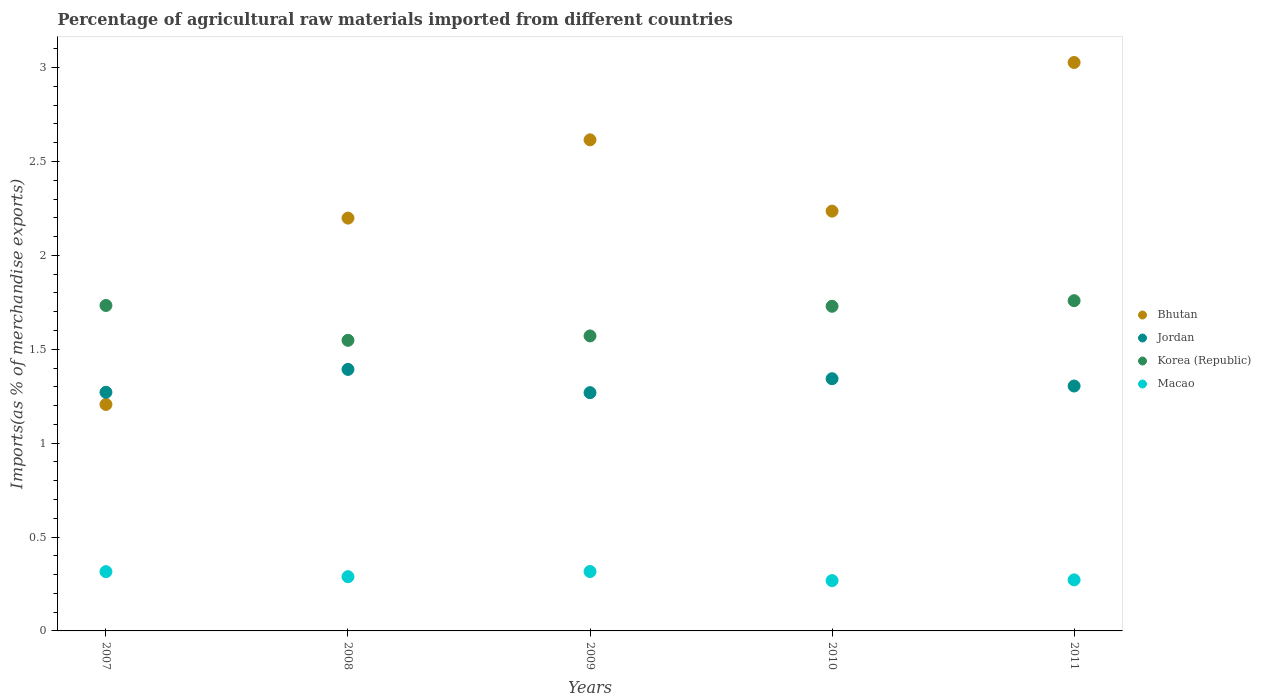What is the percentage of imports to different countries in Korea (Republic) in 2007?
Offer a terse response. 1.73. Across all years, what is the maximum percentage of imports to different countries in Bhutan?
Keep it short and to the point. 3.03. Across all years, what is the minimum percentage of imports to different countries in Jordan?
Keep it short and to the point. 1.27. In which year was the percentage of imports to different countries in Jordan maximum?
Your answer should be compact. 2008. In which year was the percentage of imports to different countries in Korea (Republic) minimum?
Keep it short and to the point. 2008. What is the total percentage of imports to different countries in Macao in the graph?
Provide a short and direct response. 1.46. What is the difference between the percentage of imports to different countries in Macao in 2007 and that in 2009?
Give a very brief answer. -0. What is the difference between the percentage of imports to different countries in Jordan in 2007 and the percentage of imports to different countries in Korea (Republic) in 2010?
Give a very brief answer. -0.46. What is the average percentage of imports to different countries in Jordan per year?
Offer a very short reply. 1.32. In the year 2008, what is the difference between the percentage of imports to different countries in Bhutan and percentage of imports to different countries in Jordan?
Your answer should be compact. 0.81. What is the ratio of the percentage of imports to different countries in Bhutan in 2009 to that in 2011?
Offer a terse response. 0.86. Is the percentage of imports to different countries in Korea (Republic) in 2008 less than that in 2011?
Give a very brief answer. Yes. Is the difference between the percentage of imports to different countries in Bhutan in 2007 and 2008 greater than the difference between the percentage of imports to different countries in Jordan in 2007 and 2008?
Offer a very short reply. No. What is the difference between the highest and the second highest percentage of imports to different countries in Bhutan?
Give a very brief answer. 0.41. What is the difference between the highest and the lowest percentage of imports to different countries in Bhutan?
Keep it short and to the point. 1.82. In how many years, is the percentage of imports to different countries in Macao greater than the average percentage of imports to different countries in Macao taken over all years?
Make the answer very short. 2. Is the percentage of imports to different countries in Korea (Republic) strictly greater than the percentage of imports to different countries in Macao over the years?
Offer a terse response. Yes. Is the percentage of imports to different countries in Jordan strictly less than the percentage of imports to different countries in Korea (Republic) over the years?
Offer a very short reply. Yes. How many years are there in the graph?
Offer a terse response. 5. Are the values on the major ticks of Y-axis written in scientific E-notation?
Offer a very short reply. No. Does the graph contain any zero values?
Your response must be concise. No. Where does the legend appear in the graph?
Provide a succinct answer. Center right. How are the legend labels stacked?
Ensure brevity in your answer.  Vertical. What is the title of the graph?
Offer a very short reply. Percentage of agricultural raw materials imported from different countries. What is the label or title of the Y-axis?
Your answer should be very brief. Imports(as % of merchandise exports). What is the Imports(as % of merchandise exports) in Bhutan in 2007?
Keep it short and to the point. 1.21. What is the Imports(as % of merchandise exports) in Jordan in 2007?
Your answer should be very brief. 1.27. What is the Imports(as % of merchandise exports) of Korea (Republic) in 2007?
Your response must be concise. 1.73. What is the Imports(as % of merchandise exports) of Macao in 2007?
Ensure brevity in your answer.  0.32. What is the Imports(as % of merchandise exports) in Bhutan in 2008?
Offer a terse response. 2.2. What is the Imports(as % of merchandise exports) in Jordan in 2008?
Give a very brief answer. 1.39. What is the Imports(as % of merchandise exports) in Korea (Republic) in 2008?
Ensure brevity in your answer.  1.55. What is the Imports(as % of merchandise exports) in Macao in 2008?
Give a very brief answer. 0.29. What is the Imports(as % of merchandise exports) of Bhutan in 2009?
Ensure brevity in your answer.  2.62. What is the Imports(as % of merchandise exports) in Jordan in 2009?
Provide a short and direct response. 1.27. What is the Imports(as % of merchandise exports) of Korea (Republic) in 2009?
Your response must be concise. 1.57. What is the Imports(as % of merchandise exports) in Macao in 2009?
Give a very brief answer. 0.32. What is the Imports(as % of merchandise exports) in Bhutan in 2010?
Make the answer very short. 2.24. What is the Imports(as % of merchandise exports) of Jordan in 2010?
Offer a terse response. 1.34. What is the Imports(as % of merchandise exports) of Korea (Republic) in 2010?
Your response must be concise. 1.73. What is the Imports(as % of merchandise exports) in Macao in 2010?
Provide a succinct answer. 0.27. What is the Imports(as % of merchandise exports) of Bhutan in 2011?
Keep it short and to the point. 3.03. What is the Imports(as % of merchandise exports) in Jordan in 2011?
Offer a very short reply. 1.3. What is the Imports(as % of merchandise exports) in Korea (Republic) in 2011?
Provide a succinct answer. 1.76. What is the Imports(as % of merchandise exports) in Macao in 2011?
Make the answer very short. 0.27. Across all years, what is the maximum Imports(as % of merchandise exports) in Bhutan?
Give a very brief answer. 3.03. Across all years, what is the maximum Imports(as % of merchandise exports) of Jordan?
Give a very brief answer. 1.39. Across all years, what is the maximum Imports(as % of merchandise exports) in Korea (Republic)?
Make the answer very short. 1.76. Across all years, what is the maximum Imports(as % of merchandise exports) in Macao?
Offer a terse response. 0.32. Across all years, what is the minimum Imports(as % of merchandise exports) of Bhutan?
Offer a very short reply. 1.21. Across all years, what is the minimum Imports(as % of merchandise exports) in Jordan?
Give a very brief answer. 1.27. Across all years, what is the minimum Imports(as % of merchandise exports) in Korea (Republic)?
Offer a very short reply. 1.55. Across all years, what is the minimum Imports(as % of merchandise exports) in Macao?
Provide a succinct answer. 0.27. What is the total Imports(as % of merchandise exports) of Bhutan in the graph?
Give a very brief answer. 11.28. What is the total Imports(as % of merchandise exports) in Jordan in the graph?
Make the answer very short. 6.58. What is the total Imports(as % of merchandise exports) in Korea (Republic) in the graph?
Your response must be concise. 8.34. What is the total Imports(as % of merchandise exports) of Macao in the graph?
Give a very brief answer. 1.46. What is the difference between the Imports(as % of merchandise exports) of Bhutan in 2007 and that in 2008?
Ensure brevity in your answer.  -0.99. What is the difference between the Imports(as % of merchandise exports) of Jordan in 2007 and that in 2008?
Your answer should be very brief. -0.12. What is the difference between the Imports(as % of merchandise exports) in Korea (Republic) in 2007 and that in 2008?
Your answer should be very brief. 0.19. What is the difference between the Imports(as % of merchandise exports) of Macao in 2007 and that in 2008?
Offer a terse response. 0.03. What is the difference between the Imports(as % of merchandise exports) in Bhutan in 2007 and that in 2009?
Offer a terse response. -1.41. What is the difference between the Imports(as % of merchandise exports) in Jordan in 2007 and that in 2009?
Your answer should be very brief. 0. What is the difference between the Imports(as % of merchandise exports) of Korea (Republic) in 2007 and that in 2009?
Keep it short and to the point. 0.16. What is the difference between the Imports(as % of merchandise exports) of Macao in 2007 and that in 2009?
Offer a terse response. -0. What is the difference between the Imports(as % of merchandise exports) of Bhutan in 2007 and that in 2010?
Make the answer very short. -1.03. What is the difference between the Imports(as % of merchandise exports) in Jordan in 2007 and that in 2010?
Your answer should be compact. -0.07. What is the difference between the Imports(as % of merchandise exports) of Korea (Republic) in 2007 and that in 2010?
Your answer should be very brief. 0. What is the difference between the Imports(as % of merchandise exports) in Macao in 2007 and that in 2010?
Ensure brevity in your answer.  0.05. What is the difference between the Imports(as % of merchandise exports) of Bhutan in 2007 and that in 2011?
Provide a succinct answer. -1.82. What is the difference between the Imports(as % of merchandise exports) of Jordan in 2007 and that in 2011?
Your answer should be very brief. -0.03. What is the difference between the Imports(as % of merchandise exports) in Korea (Republic) in 2007 and that in 2011?
Offer a terse response. -0.03. What is the difference between the Imports(as % of merchandise exports) of Macao in 2007 and that in 2011?
Make the answer very short. 0.04. What is the difference between the Imports(as % of merchandise exports) in Bhutan in 2008 and that in 2009?
Offer a terse response. -0.42. What is the difference between the Imports(as % of merchandise exports) of Jordan in 2008 and that in 2009?
Your answer should be compact. 0.12. What is the difference between the Imports(as % of merchandise exports) of Korea (Republic) in 2008 and that in 2009?
Ensure brevity in your answer.  -0.02. What is the difference between the Imports(as % of merchandise exports) in Macao in 2008 and that in 2009?
Your answer should be very brief. -0.03. What is the difference between the Imports(as % of merchandise exports) in Bhutan in 2008 and that in 2010?
Ensure brevity in your answer.  -0.04. What is the difference between the Imports(as % of merchandise exports) of Jordan in 2008 and that in 2010?
Offer a very short reply. 0.05. What is the difference between the Imports(as % of merchandise exports) of Korea (Republic) in 2008 and that in 2010?
Your answer should be compact. -0.18. What is the difference between the Imports(as % of merchandise exports) of Macao in 2008 and that in 2010?
Keep it short and to the point. 0.02. What is the difference between the Imports(as % of merchandise exports) in Bhutan in 2008 and that in 2011?
Your answer should be compact. -0.83. What is the difference between the Imports(as % of merchandise exports) of Jordan in 2008 and that in 2011?
Give a very brief answer. 0.09. What is the difference between the Imports(as % of merchandise exports) in Korea (Republic) in 2008 and that in 2011?
Provide a succinct answer. -0.21. What is the difference between the Imports(as % of merchandise exports) in Macao in 2008 and that in 2011?
Your answer should be compact. 0.02. What is the difference between the Imports(as % of merchandise exports) of Bhutan in 2009 and that in 2010?
Ensure brevity in your answer.  0.38. What is the difference between the Imports(as % of merchandise exports) of Jordan in 2009 and that in 2010?
Offer a very short reply. -0.07. What is the difference between the Imports(as % of merchandise exports) in Korea (Republic) in 2009 and that in 2010?
Make the answer very short. -0.16. What is the difference between the Imports(as % of merchandise exports) in Macao in 2009 and that in 2010?
Your answer should be compact. 0.05. What is the difference between the Imports(as % of merchandise exports) in Bhutan in 2009 and that in 2011?
Offer a very short reply. -0.41. What is the difference between the Imports(as % of merchandise exports) of Jordan in 2009 and that in 2011?
Give a very brief answer. -0.04. What is the difference between the Imports(as % of merchandise exports) in Korea (Republic) in 2009 and that in 2011?
Make the answer very short. -0.19. What is the difference between the Imports(as % of merchandise exports) of Macao in 2009 and that in 2011?
Give a very brief answer. 0.04. What is the difference between the Imports(as % of merchandise exports) in Bhutan in 2010 and that in 2011?
Your answer should be compact. -0.79. What is the difference between the Imports(as % of merchandise exports) of Jordan in 2010 and that in 2011?
Provide a short and direct response. 0.04. What is the difference between the Imports(as % of merchandise exports) in Korea (Republic) in 2010 and that in 2011?
Your answer should be compact. -0.03. What is the difference between the Imports(as % of merchandise exports) of Macao in 2010 and that in 2011?
Make the answer very short. -0. What is the difference between the Imports(as % of merchandise exports) of Bhutan in 2007 and the Imports(as % of merchandise exports) of Jordan in 2008?
Offer a very short reply. -0.19. What is the difference between the Imports(as % of merchandise exports) of Bhutan in 2007 and the Imports(as % of merchandise exports) of Korea (Republic) in 2008?
Provide a succinct answer. -0.34. What is the difference between the Imports(as % of merchandise exports) of Bhutan in 2007 and the Imports(as % of merchandise exports) of Macao in 2008?
Provide a succinct answer. 0.92. What is the difference between the Imports(as % of merchandise exports) of Jordan in 2007 and the Imports(as % of merchandise exports) of Korea (Republic) in 2008?
Keep it short and to the point. -0.28. What is the difference between the Imports(as % of merchandise exports) in Jordan in 2007 and the Imports(as % of merchandise exports) in Macao in 2008?
Give a very brief answer. 0.98. What is the difference between the Imports(as % of merchandise exports) in Korea (Republic) in 2007 and the Imports(as % of merchandise exports) in Macao in 2008?
Provide a short and direct response. 1.44. What is the difference between the Imports(as % of merchandise exports) of Bhutan in 2007 and the Imports(as % of merchandise exports) of Jordan in 2009?
Offer a very short reply. -0.06. What is the difference between the Imports(as % of merchandise exports) in Bhutan in 2007 and the Imports(as % of merchandise exports) in Korea (Republic) in 2009?
Make the answer very short. -0.36. What is the difference between the Imports(as % of merchandise exports) in Bhutan in 2007 and the Imports(as % of merchandise exports) in Macao in 2009?
Offer a terse response. 0.89. What is the difference between the Imports(as % of merchandise exports) in Jordan in 2007 and the Imports(as % of merchandise exports) in Korea (Republic) in 2009?
Your response must be concise. -0.3. What is the difference between the Imports(as % of merchandise exports) in Jordan in 2007 and the Imports(as % of merchandise exports) in Macao in 2009?
Your response must be concise. 0.95. What is the difference between the Imports(as % of merchandise exports) of Korea (Republic) in 2007 and the Imports(as % of merchandise exports) of Macao in 2009?
Ensure brevity in your answer.  1.42. What is the difference between the Imports(as % of merchandise exports) in Bhutan in 2007 and the Imports(as % of merchandise exports) in Jordan in 2010?
Make the answer very short. -0.14. What is the difference between the Imports(as % of merchandise exports) of Bhutan in 2007 and the Imports(as % of merchandise exports) of Korea (Republic) in 2010?
Ensure brevity in your answer.  -0.52. What is the difference between the Imports(as % of merchandise exports) in Bhutan in 2007 and the Imports(as % of merchandise exports) in Macao in 2010?
Offer a very short reply. 0.94. What is the difference between the Imports(as % of merchandise exports) in Jordan in 2007 and the Imports(as % of merchandise exports) in Korea (Republic) in 2010?
Provide a short and direct response. -0.46. What is the difference between the Imports(as % of merchandise exports) of Korea (Republic) in 2007 and the Imports(as % of merchandise exports) of Macao in 2010?
Your answer should be compact. 1.47. What is the difference between the Imports(as % of merchandise exports) in Bhutan in 2007 and the Imports(as % of merchandise exports) in Jordan in 2011?
Make the answer very short. -0.1. What is the difference between the Imports(as % of merchandise exports) in Bhutan in 2007 and the Imports(as % of merchandise exports) in Korea (Republic) in 2011?
Make the answer very short. -0.55. What is the difference between the Imports(as % of merchandise exports) of Bhutan in 2007 and the Imports(as % of merchandise exports) of Macao in 2011?
Provide a succinct answer. 0.93. What is the difference between the Imports(as % of merchandise exports) of Jordan in 2007 and the Imports(as % of merchandise exports) of Korea (Republic) in 2011?
Make the answer very short. -0.49. What is the difference between the Imports(as % of merchandise exports) in Korea (Republic) in 2007 and the Imports(as % of merchandise exports) in Macao in 2011?
Make the answer very short. 1.46. What is the difference between the Imports(as % of merchandise exports) in Bhutan in 2008 and the Imports(as % of merchandise exports) in Jordan in 2009?
Your answer should be compact. 0.93. What is the difference between the Imports(as % of merchandise exports) of Bhutan in 2008 and the Imports(as % of merchandise exports) of Korea (Republic) in 2009?
Offer a very short reply. 0.63. What is the difference between the Imports(as % of merchandise exports) of Bhutan in 2008 and the Imports(as % of merchandise exports) of Macao in 2009?
Keep it short and to the point. 1.88. What is the difference between the Imports(as % of merchandise exports) of Jordan in 2008 and the Imports(as % of merchandise exports) of Korea (Republic) in 2009?
Make the answer very short. -0.18. What is the difference between the Imports(as % of merchandise exports) of Jordan in 2008 and the Imports(as % of merchandise exports) of Macao in 2009?
Make the answer very short. 1.08. What is the difference between the Imports(as % of merchandise exports) in Korea (Republic) in 2008 and the Imports(as % of merchandise exports) in Macao in 2009?
Make the answer very short. 1.23. What is the difference between the Imports(as % of merchandise exports) of Bhutan in 2008 and the Imports(as % of merchandise exports) of Jordan in 2010?
Give a very brief answer. 0.86. What is the difference between the Imports(as % of merchandise exports) in Bhutan in 2008 and the Imports(as % of merchandise exports) in Korea (Republic) in 2010?
Offer a very short reply. 0.47. What is the difference between the Imports(as % of merchandise exports) in Bhutan in 2008 and the Imports(as % of merchandise exports) in Macao in 2010?
Provide a short and direct response. 1.93. What is the difference between the Imports(as % of merchandise exports) of Jordan in 2008 and the Imports(as % of merchandise exports) of Korea (Republic) in 2010?
Your answer should be compact. -0.34. What is the difference between the Imports(as % of merchandise exports) of Jordan in 2008 and the Imports(as % of merchandise exports) of Macao in 2010?
Your answer should be compact. 1.12. What is the difference between the Imports(as % of merchandise exports) in Korea (Republic) in 2008 and the Imports(as % of merchandise exports) in Macao in 2010?
Your response must be concise. 1.28. What is the difference between the Imports(as % of merchandise exports) in Bhutan in 2008 and the Imports(as % of merchandise exports) in Jordan in 2011?
Offer a very short reply. 0.89. What is the difference between the Imports(as % of merchandise exports) of Bhutan in 2008 and the Imports(as % of merchandise exports) of Korea (Republic) in 2011?
Ensure brevity in your answer.  0.44. What is the difference between the Imports(as % of merchandise exports) of Bhutan in 2008 and the Imports(as % of merchandise exports) of Macao in 2011?
Keep it short and to the point. 1.93. What is the difference between the Imports(as % of merchandise exports) of Jordan in 2008 and the Imports(as % of merchandise exports) of Korea (Republic) in 2011?
Give a very brief answer. -0.37. What is the difference between the Imports(as % of merchandise exports) of Jordan in 2008 and the Imports(as % of merchandise exports) of Macao in 2011?
Provide a short and direct response. 1.12. What is the difference between the Imports(as % of merchandise exports) in Korea (Republic) in 2008 and the Imports(as % of merchandise exports) in Macao in 2011?
Ensure brevity in your answer.  1.28. What is the difference between the Imports(as % of merchandise exports) of Bhutan in 2009 and the Imports(as % of merchandise exports) of Jordan in 2010?
Give a very brief answer. 1.27. What is the difference between the Imports(as % of merchandise exports) in Bhutan in 2009 and the Imports(as % of merchandise exports) in Korea (Republic) in 2010?
Give a very brief answer. 0.89. What is the difference between the Imports(as % of merchandise exports) in Bhutan in 2009 and the Imports(as % of merchandise exports) in Macao in 2010?
Make the answer very short. 2.35. What is the difference between the Imports(as % of merchandise exports) in Jordan in 2009 and the Imports(as % of merchandise exports) in Korea (Republic) in 2010?
Your answer should be very brief. -0.46. What is the difference between the Imports(as % of merchandise exports) of Jordan in 2009 and the Imports(as % of merchandise exports) of Macao in 2010?
Provide a succinct answer. 1. What is the difference between the Imports(as % of merchandise exports) in Korea (Republic) in 2009 and the Imports(as % of merchandise exports) in Macao in 2010?
Ensure brevity in your answer.  1.3. What is the difference between the Imports(as % of merchandise exports) in Bhutan in 2009 and the Imports(as % of merchandise exports) in Jordan in 2011?
Your answer should be compact. 1.31. What is the difference between the Imports(as % of merchandise exports) in Bhutan in 2009 and the Imports(as % of merchandise exports) in Korea (Republic) in 2011?
Offer a terse response. 0.86. What is the difference between the Imports(as % of merchandise exports) of Bhutan in 2009 and the Imports(as % of merchandise exports) of Macao in 2011?
Give a very brief answer. 2.34. What is the difference between the Imports(as % of merchandise exports) in Jordan in 2009 and the Imports(as % of merchandise exports) in Korea (Republic) in 2011?
Offer a very short reply. -0.49. What is the difference between the Imports(as % of merchandise exports) of Jordan in 2009 and the Imports(as % of merchandise exports) of Macao in 2011?
Offer a terse response. 1. What is the difference between the Imports(as % of merchandise exports) of Korea (Republic) in 2009 and the Imports(as % of merchandise exports) of Macao in 2011?
Ensure brevity in your answer.  1.3. What is the difference between the Imports(as % of merchandise exports) in Bhutan in 2010 and the Imports(as % of merchandise exports) in Jordan in 2011?
Your answer should be compact. 0.93. What is the difference between the Imports(as % of merchandise exports) in Bhutan in 2010 and the Imports(as % of merchandise exports) in Korea (Republic) in 2011?
Ensure brevity in your answer.  0.48. What is the difference between the Imports(as % of merchandise exports) in Bhutan in 2010 and the Imports(as % of merchandise exports) in Macao in 2011?
Your response must be concise. 1.96. What is the difference between the Imports(as % of merchandise exports) in Jordan in 2010 and the Imports(as % of merchandise exports) in Korea (Republic) in 2011?
Your response must be concise. -0.42. What is the difference between the Imports(as % of merchandise exports) of Jordan in 2010 and the Imports(as % of merchandise exports) of Macao in 2011?
Your answer should be compact. 1.07. What is the difference between the Imports(as % of merchandise exports) of Korea (Republic) in 2010 and the Imports(as % of merchandise exports) of Macao in 2011?
Your answer should be compact. 1.46. What is the average Imports(as % of merchandise exports) of Bhutan per year?
Offer a very short reply. 2.26. What is the average Imports(as % of merchandise exports) in Jordan per year?
Give a very brief answer. 1.32. What is the average Imports(as % of merchandise exports) of Korea (Republic) per year?
Your response must be concise. 1.67. What is the average Imports(as % of merchandise exports) in Macao per year?
Your response must be concise. 0.29. In the year 2007, what is the difference between the Imports(as % of merchandise exports) of Bhutan and Imports(as % of merchandise exports) of Jordan?
Your response must be concise. -0.06. In the year 2007, what is the difference between the Imports(as % of merchandise exports) in Bhutan and Imports(as % of merchandise exports) in Korea (Republic)?
Provide a succinct answer. -0.53. In the year 2007, what is the difference between the Imports(as % of merchandise exports) in Bhutan and Imports(as % of merchandise exports) in Macao?
Provide a short and direct response. 0.89. In the year 2007, what is the difference between the Imports(as % of merchandise exports) in Jordan and Imports(as % of merchandise exports) in Korea (Republic)?
Ensure brevity in your answer.  -0.46. In the year 2007, what is the difference between the Imports(as % of merchandise exports) in Jordan and Imports(as % of merchandise exports) in Macao?
Offer a very short reply. 0.96. In the year 2007, what is the difference between the Imports(as % of merchandise exports) of Korea (Republic) and Imports(as % of merchandise exports) of Macao?
Your answer should be compact. 1.42. In the year 2008, what is the difference between the Imports(as % of merchandise exports) of Bhutan and Imports(as % of merchandise exports) of Jordan?
Give a very brief answer. 0.81. In the year 2008, what is the difference between the Imports(as % of merchandise exports) of Bhutan and Imports(as % of merchandise exports) of Korea (Republic)?
Your answer should be compact. 0.65. In the year 2008, what is the difference between the Imports(as % of merchandise exports) in Bhutan and Imports(as % of merchandise exports) in Macao?
Offer a terse response. 1.91. In the year 2008, what is the difference between the Imports(as % of merchandise exports) in Jordan and Imports(as % of merchandise exports) in Korea (Republic)?
Give a very brief answer. -0.15. In the year 2008, what is the difference between the Imports(as % of merchandise exports) of Jordan and Imports(as % of merchandise exports) of Macao?
Ensure brevity in your answer.  1.1. In the year 2008, what is the difference between the Imports(as % of merchandise exports) of Korea (Republic) and Imports(as % of merchandise exports) of Macao?
Offer a terse response. 1.26. In the year 2009, what is the difference between the Imports(as % of merchandise exports) in Bhutan and Imports(as % of merchandise exports) in Jordan?
Make the answer very short. 1.35. In the year 2009, what is the difference between the Imports(as % of merchandise exports) in Bhutan and Imports(as % of merchandise exports) in Korea (Republic)?
Give a very brief answer. 1.04. In the year 2009, what is the difference between the Imports(as % of merchandise exports) of Bhutan and Imports(as % of merchandise exports) of Macao?
Your answer should be compact. 2.3. In the year 2009, what is the difference between the Imports(as % of merchandise exports) in Jordan and Imports(as % of merchandise exports) in Korea (Republic)?
Your answer should be very brief. -0.3. In the year 2009, what is the difference between the Imports(as % of merchandise exports) of Jordan and Imports(as % of merchandise exports) of Macao?
Your answer should be very brief. 0.95. In the year 2009, what is the difference between the Imports(as % of merchandise exports) in Korea (Republic) and Imports(as % of merchandise exports) in Macao?
Offer a terse response. 1.25. In the year 2010, what is the difference between the Imports(as % of merchandise exports) of Bhutan and Imports(as % of merchandise exports) of Jordan?
Keep it short and to the point. 0.89. In the year 2010, what is the difference between the Imports(as % of merchandise exports) of Bhutan and Imports(as % of merchandise exports) of Korea (Republic)?
Ensure brevity in your answer.  0.51. In the year 2010, what is the difference between the Imports(as % of merchandise exports) in Bhutan and Imports(as % of merchandise exports) in Macao?
Keep it short and to the point. 1.97. In the year 2010, what is the difference between the Imports(as % of merchandise exports) of Jordan and Imports(as % of merchandise exports) of Korea (Republic)?
Provide a short and direct response. -0.39. In the year 2010, what is the difference between the Imports(as % of merchandise exports) in Jordan and Imports(as % of merchandise exports) in Macao?
Your answer should be compact. 1.08. In the year 2010, what is the difference between the Imports(as % of merchandise exports) of Korea (Republic) and Imports(as % of merchandise exports) of Macao?
Your answer should be compact. 1.46. In the year 2011, what is the difference between the Imports(as % of merchandise exports) in Bhutan and Imports(as % of merchandise exports) in Jordan?
Keep it short and to the point. 1.72. In the year 2011, what is the difference between the Imports(as % of merchandise exports) of Bhutan and Imports(as % of merchandise exports) of Korea (Republic)?
Your answer should be compact. 1.27. In the year 2011, what is the difference between the Imports(as % of merchandise exports) in Bhutan and Imports(as % of merchandise exports) in Macao?
Provide a succinct answer. 2.76. In the year 2011, what is the difference between the Imports(as % of merchandise exports) in Jordan and Imports(as % of merchandise exports) in Korea (Republic)?
Keep it short and to the point. -0.45. In the year 2011, what is the difference between the Imports(as % of merchandise exports) in Jordan and Imports(as % of merchandise exports) in Macao?
Make the answer very short. 1.03. In the year 2011, what is the difference between the Imports(as % of merchandise exports) of Korea (Republic) and Imports(as % of merchandise exports) of Macao?
Keep it short and to the point. 1.49. What is the ratio of the Imports(as % of merchandise exports) in Bhutan in 2007 to that in 2008?
Make the answer very short. 0.55. What is the ratio of the Imports(as % of merchandise exports) of Jordan in 2007 to that in 2008?
Keep it short and to the point. 0.91. What is the ratio of the Imports(as % of merchandise exports) in Korea (Republic) in 2007 to that in 2008?
Your answer should be compact. 1.12. What is the ratio of the Imports(as % of merchandise exports) in Macao in 2007 to that in 2008?
Your answer should be very brief. 1.09. What is the ratio of the Imports(as % of merchandise exports) of Bhutan in 2007 to that in 2009?
Offer a very short reply. 0.46. What is the ratio of the Imports(as % of merchandise exports) in Korea (Republic) in 2007 to that in 2009?
Make the answer very short. 1.1. What is the ratio of the Imports(as % of merchandise exports) of Macao in 2007 to that in 2009?
Your answer should be compact. 1. What is the ratio of the Imports(as % of merchandise exports) of Bhutan in 2007 to that in 2010?
Keep it short and to the point. 0.54. What is the ratio of the Imports(as % of merchandise exports) of Jordan in 2007 to that in 2010?
Keep it short and to the point. 0.95. What is the ratio of the Imports(as % of merchandise exports) in Korea (Republic) in 2007 to that in 2010?
Ensure brevity in your answer.  1. What is the ratio of the Imports(as % of merchandise exports) of Macao in 2007 to that in 2010?
Ensure brevity in your answer.  1.18. What is the ratio of the Imports(as % of merchandise exports) of Bhutan in 2007 to that in 2011?
Your response must be concise. 0.4. What is the ratio of the Imports(as % of merchandise exports) in Jordan in 2007 to that in 2011?
Provide a short and direct response. 0.97. What is the ratio of the Imports(as % of merchandise exports) in Korea (Republic) in 2007 to that in 2011?
Ensure brevity in your answer.  0.99. What is the ratio of the Imports(as % of merchandise exports) of Macao in 2007 to that in 2011?
Your answer should be very brief. 1.16. What is the ratio of the Imports(as % of merchandise exports) of Bhutan in 2008 to that in 2009?
Provide a short and direct response. 0.84. What is the ratio of the Imports(as % of merchandise exports) in Jordan in 2008 to that in 2009?
Provide a succinct answer. 1.1. What is the ratio of the Imports(as % of merchandise exports) in Korea (Republic) in 2008 to that in 2009?
Provide a short and direct response. 0.99. What is the ratio of the Imports(as % of merchandise exports) in Macao in 2008 to that in 2009?
Provide a succinct answer. 0.91. What is the ratio of the Imports(as % of merchandise exports) in Bhutan in 2008 to that in 2010?
Offer a very short reply. 0.98. What is the ratio of the Imports(as % of merchandise exports) in Jordan in 2008 to that in 2010?
Ensure brevity in your answer.  1.04. What is the ratio of the Imports(as % of merchandise exports) in Korea (Republic) in 2008 to that in 2010?
Ensure brevity in your answer.  0.9. What is the ratio of the Imports(as % of merchandise exports) in Macao in 2008 to that in 2010?
Provide a short and direct response. 1.08. What is the ratio of the Imports(as % of merchandise exports) of Bhutan in 2008 to that in 2011?
Give a very brief answer. 0.73. What is the ratio of the Imports(as % of merchandise exports) of Jordan in 2008 to that in 2011?
Your answer should be very brief. 1.07. What is the ratio of the Imports(as % of merchandise exports) of Korea (Republic) in 2008 to that in 2011?
Ensure brevity in your answer.  0.88. What is the ratio of the Imports(as % of merchandise exports) in Bhutan in 2009 to that in 2010?
Offer a terse response. 1.17. What is the ratio of the Imports(as % of merchandise exports) of Jordan in 2009 to that in 2010?
Provide a short and direct response. 0.94. What is the ratio of the Imports(as % of merchandise exports) in Korea (Republic) in 2009 to that in 2010?
Keep it short and to the point. 0.91. What is the ratio of the Imports(as % of merchandise exports) in Macao in 2009 to that in 2010?
Make the answer very short. 1.18. What is the ratio of the Imports(as % of merchandise exports) in Bhutan in 2009 to that in 2011?
Offer a very short reply. 0.86. What is the ratio of the Imports(as % of merchandise exports) of Jordan in 2009 to that in 2011?
Make the answer very short. 0.97. What is the ratio of the Imports(as % of merchandise exports) in Korea (Republic) in 2009 to that in 2011?
Offer a terse response. 0.89. What is the ratio of the Imports(as % of merchandise exports) of Macao in 2009 to that in 2011?
Give a very brief answer. 1.16. What is the ratio of the Imports(as % of merchandise exports) in Bhutan in 2010 to that in 2011?
Offer a terse response. 0.74. What is the ratio of the Imports(as % of merchandise exports) of Jordan in 2010 to that in 2011?
Provide a short and direct response. 1.03. What is the ratio of the Imports(as % of merchandise exports) of Korea (Republic) in 2010 to that in 2011?
Make the answer very short. 0.98. What is the ratio of the Imports(as % of merchandise exports) of Macao in 2010 to that in 2011?
Your answer should be compact. 0.99. What is the difference between the highest and the second highest Imports(as % of merchandise exports) in Bhutan?
Your response must be concise. 0.41. What is the difference between the highest and the second highest Imports(as % of merchandise exports) of Jordan?
Ensure brevity in your answer.  0.05. What is the difference between the highest and the second highest Imports(as % of merchandise exports) of Korea (Republic)?
Provide a succinct answer. 0.03. What is the difference between the highest and the second highest Imports(as % of merchandise exports) in Macao?
Keep it short and to the point. 0. What is the difference between the highest and the lowest Imports(as % of merchandise exports) in Bhutan?
Offer a very short reply. 1.82. What is the difference between the highest and the lowest Imports(as % of merchandise exports) of Jordan?
Ensure brevity in your answer.  0.12. What is the difference between the highest and the lowest Imports(as % of merchandise exports) of Korea (Republic)?
Ensure brevity in your answer.  0.21. What is the difference between the highest and the lowest Imports(as % of merchandise exports) in Macao?
Offer a terse response. 0.05. 